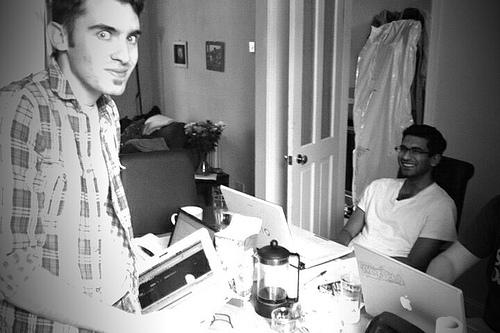How does the seated man think the standing man is acting?

Choices:
A) guilty
B) funny
C) depressed
D) whiny funny 